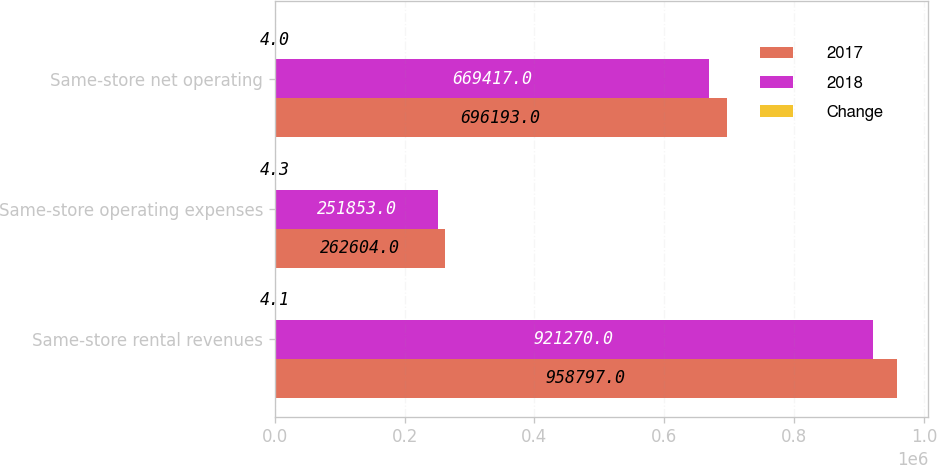<chart> <loc_0><loc_0><loc_500><loc_500><stacked_bar_chart><ecel><fcel>Same-store rental revenues<fcel>Same-store operating expenses<fcel>Same-store net operating<nl><fcel>2017<fcel>958797<fcel>262604<fcel>696193<nl><fcel>2018<fcel>921270<fcel>251853<fcel>669417<nl><fcel>Change<fcel>4.1<fcel>4.3<fcel>4<nl></chart> 